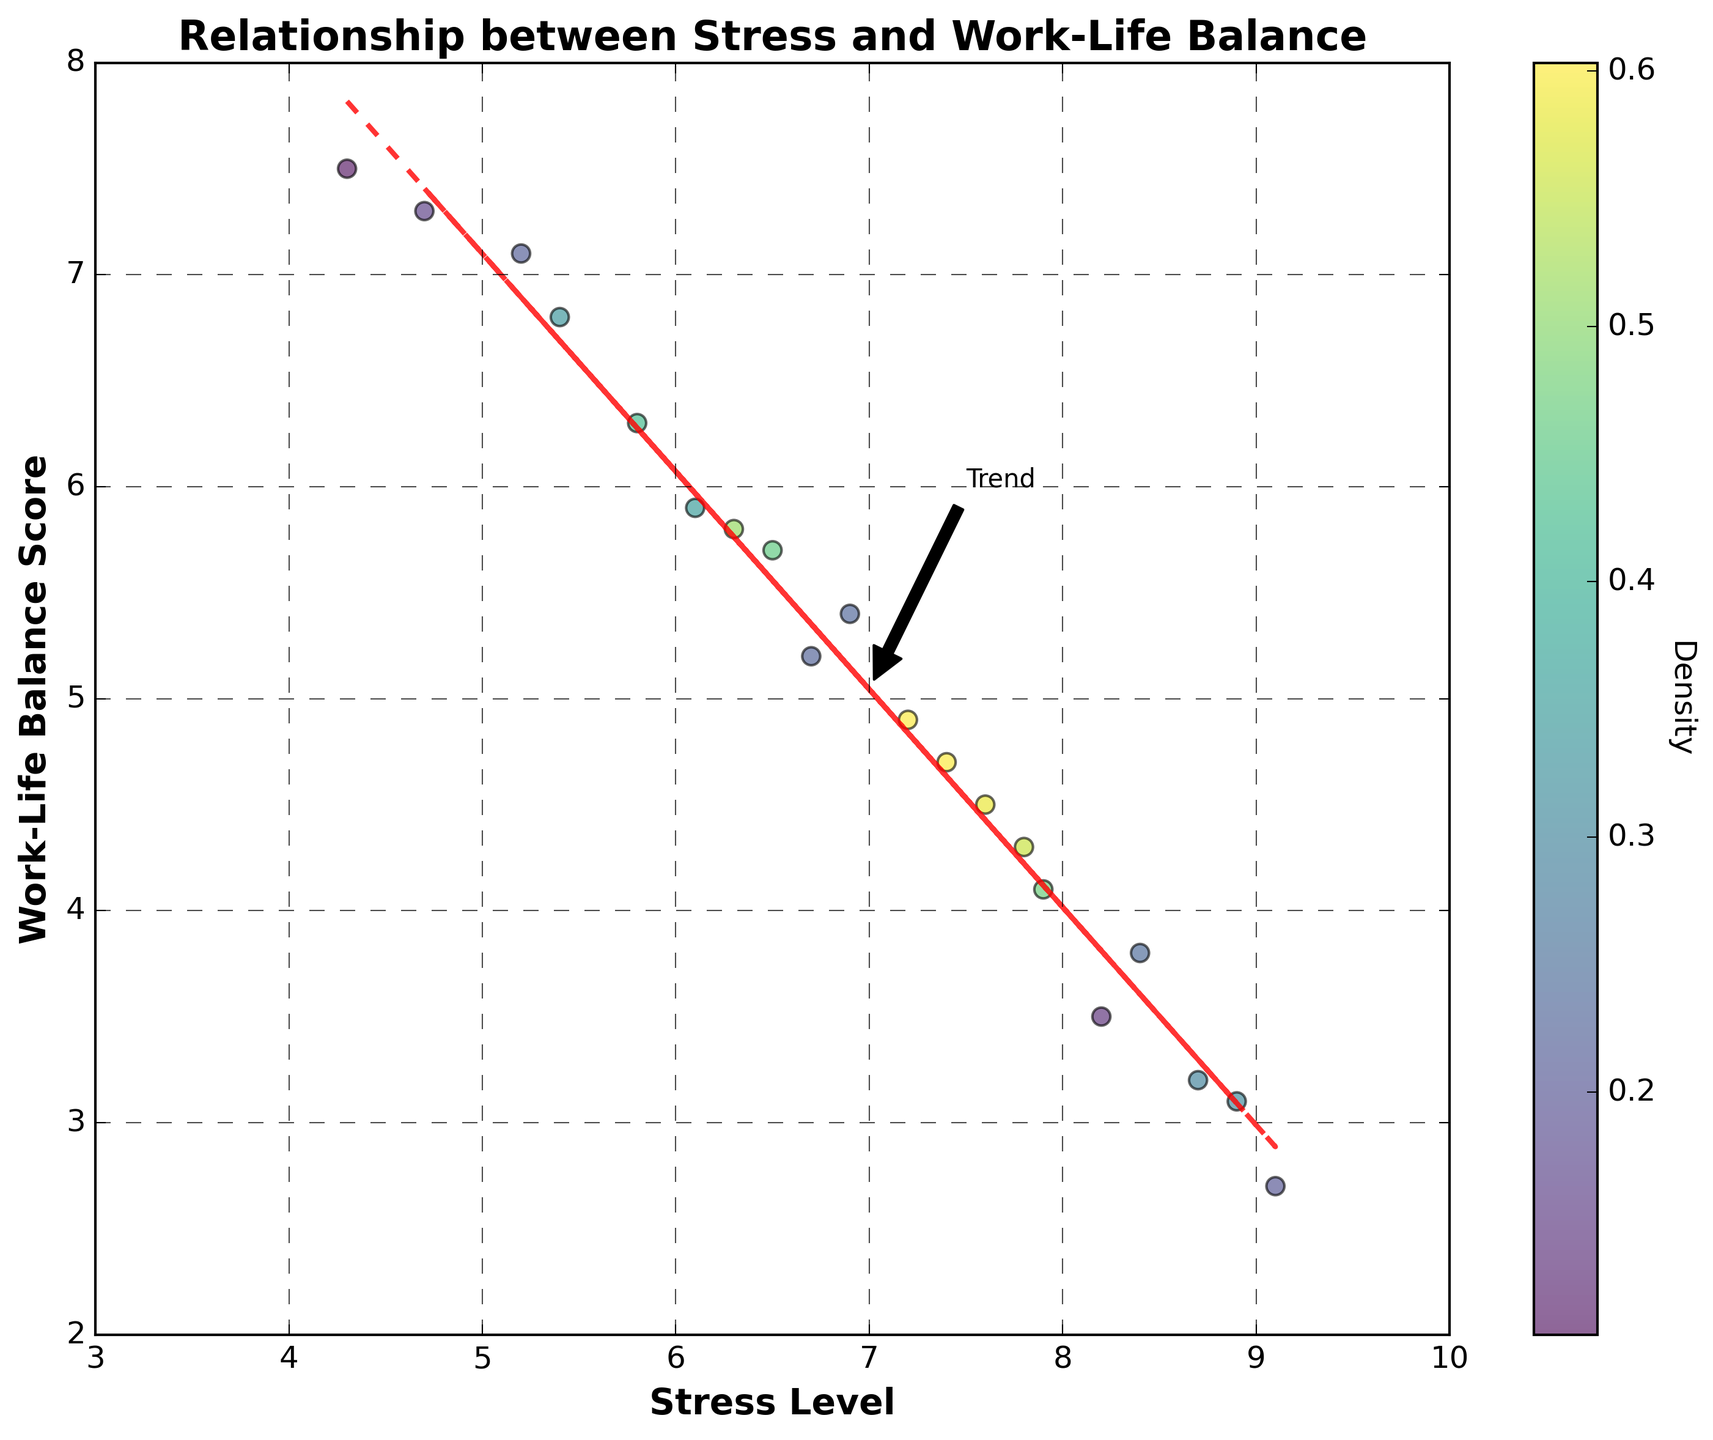How many data points are plotted in the figure? By counting the individual points within the scatter plot, we see there are 20 data points, corresponding to the 20 pairs of stress levels and work-life balance scores from the dataset.
Answer: 20 What is the title of the figure? The plot title is displayed at the top center of the figure. It reads "Relationship between Stress and Work-Life Balance."
Answer: Relationship between Stress and Work-Life Balance Which axis represents the work-life balance score? The vertical axis (y-axis) is labeled "Work-Life Balance Score." This indicates it represents work-life balance scores.
Answer: y-axis What is the range of the stress levels shown in the figure? The x-axis represents stress levels. The plot limits range from 3 to 10 for the stress levels.
Answer: 3 to 10 What color represents the highest density of points? The color bar on the right side of the figure indicates density, with darker or more intense shades of the colormap typically representing higher densities. The highest density is shown in a dark green color.
Answer: dark green What does the red dashed line represent in the plot? The red dashed line is a trend line added to indicate the general relationship between stress level and work-life balance score, as calculated using a linear fit (trendline).
Answer: trend line Where is the highest point density located? Looking at the density coloring in the scatter plot and the color bar, the highest density of points appears to be around stress levels 7 to 8 and work-life balance scores 4 to 5.
Answer: stress levels 7-8, balance scores 4-5 What is the observed trend between stress levels and work-life balance scores? By observing the trend line, we see that as stress levels increase, the work-life balance scores tend to decrease. This indicates a negative correlation.
Answer: negative correlation Is there any annotation present in the plot and what does it indicate? Yes, there is an annotation labeled "Trend" near the trend line, indicating the general relationship or trend between stress levels and work-life balance scores.
Answer: Trend annotation Compare the highest recorded stress level to the lowest work-life balance score. The highest recorded stress level on the x-axis is 9.1, and the lowest work-life balance score on the y-axis is 2.7.
Answer: 9.1 and 2.7 